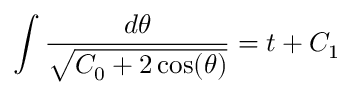Convert formula to latex. <formula><loc_0><loc_0><loc_500><loc_500>\int { \frac { d \theta } { \sqrt { C _ { 0 } + 2 \cos ( \theta ) } } } = t + C _ { 1 }</formula> 